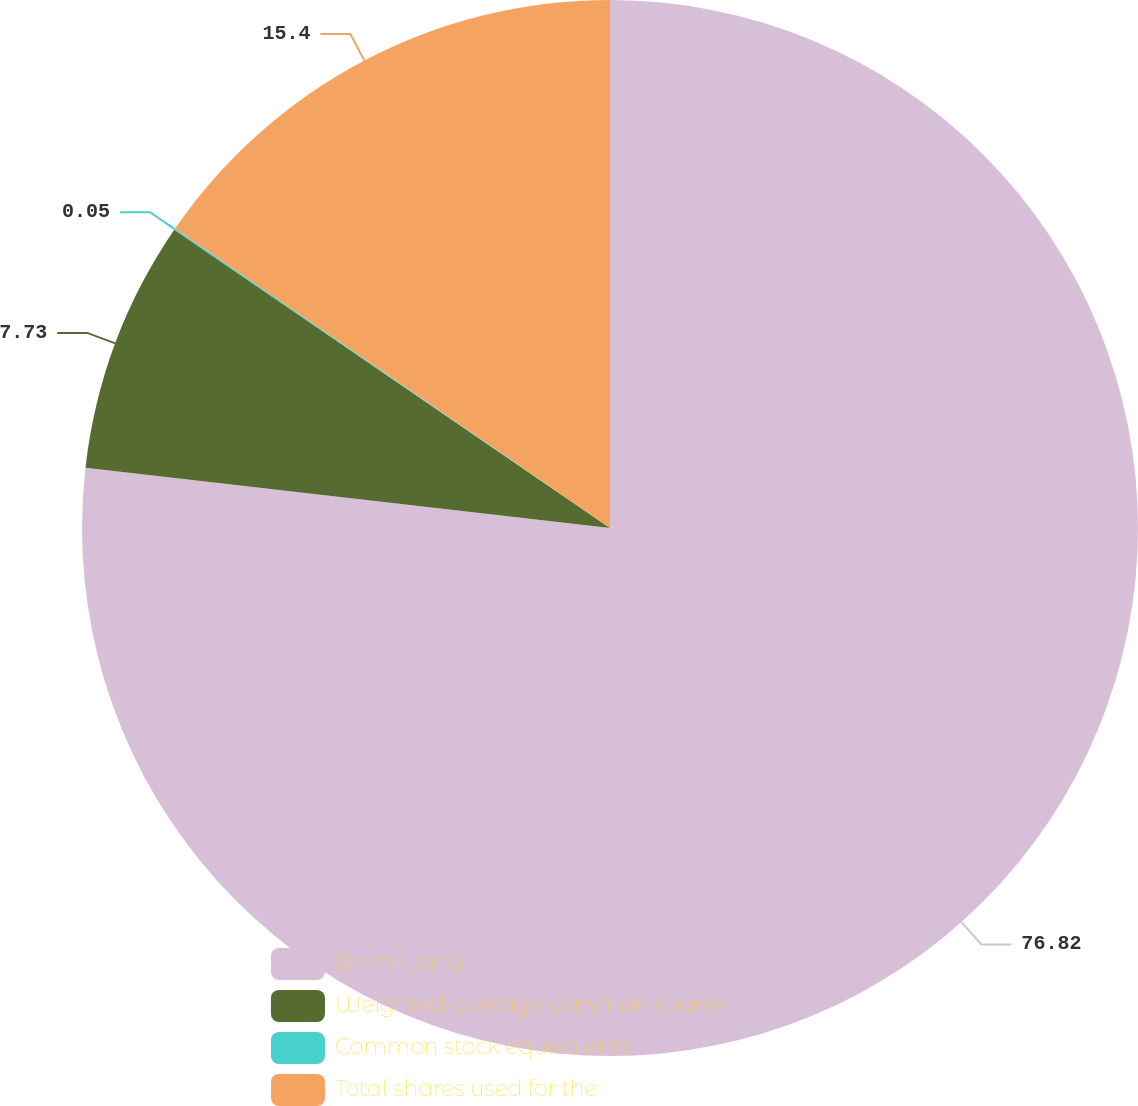Convert chart. <chart><loc_0><loc_0><loc_500><loc_500><pie_chart><fcel>(In millions)<fcel>Weighted-average common shares<fcel>Common stock equivalents<fcel>Total shares used for the<nl><fcel>76.82%<fcel>7.73%<fcel>0.05%<fcel>15.4%<nl></chart> 